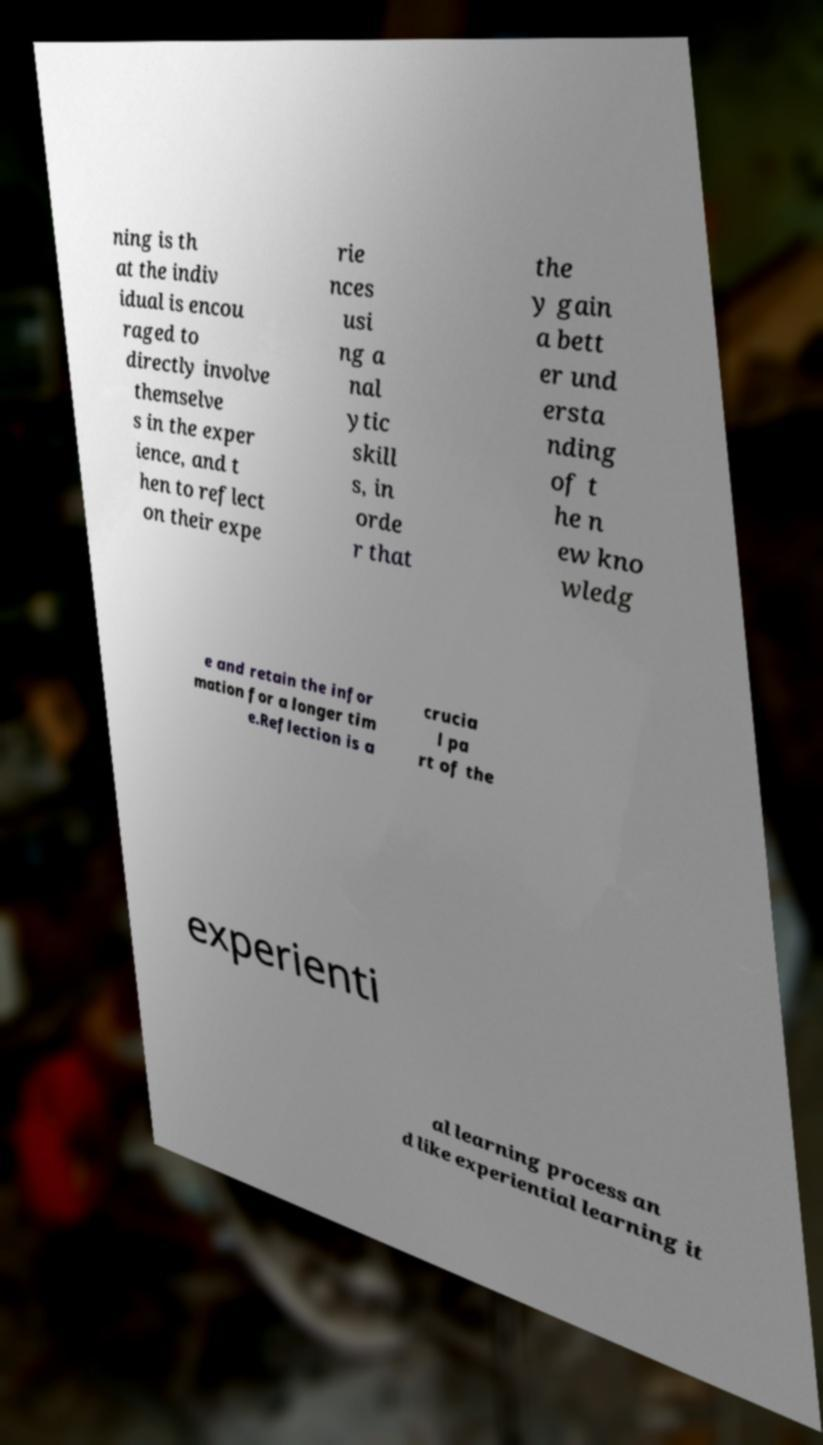Could you assist in decoding the text presented in this image and type it out clearly? ning is th at the indiv idual is encou raged to directly involve themselve s in the exper ience, and t hen to reflect on their expe rie nces usi ng a nal ytic skill s, in orde r that the y gain a bett er und ersta nding of t he n ew kno wledg e and retain the infor mation for a longer tim e.Reflection is a crucia l pa rt of the experienti al learning process an d like experiential learning it 